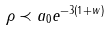Convert formula to latex. <formula><loc_0><loc_0><loc_500><loc_500>\rho \prec a _ { 0 } e ^ { - 3 ( 1 + w ) }</formula> 